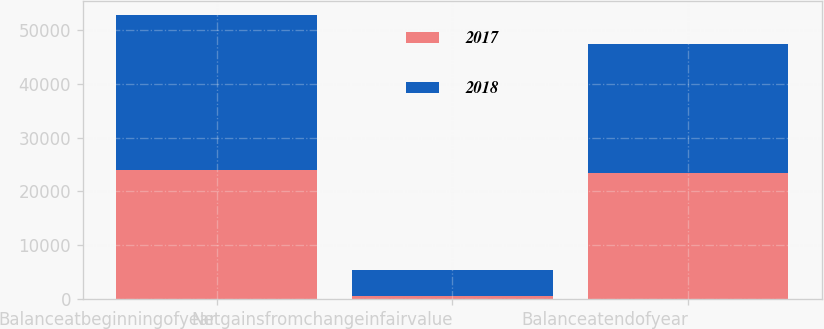Convert chart. <chart><loc_0><loc_0><loc_500><loc_500><stacked_bar_chart><ecel><fcel>Balanceatbeginningofyear<fcel>Netgainsfromchangeinfairvalue<fcel>Balanceatendofyear<nl><fcel>2017<fcel>23980<fcel>540<fcel>23440<nl><fcel>2018<fcel>28770<fcel>4790<fcel>23980<nl></chart> 